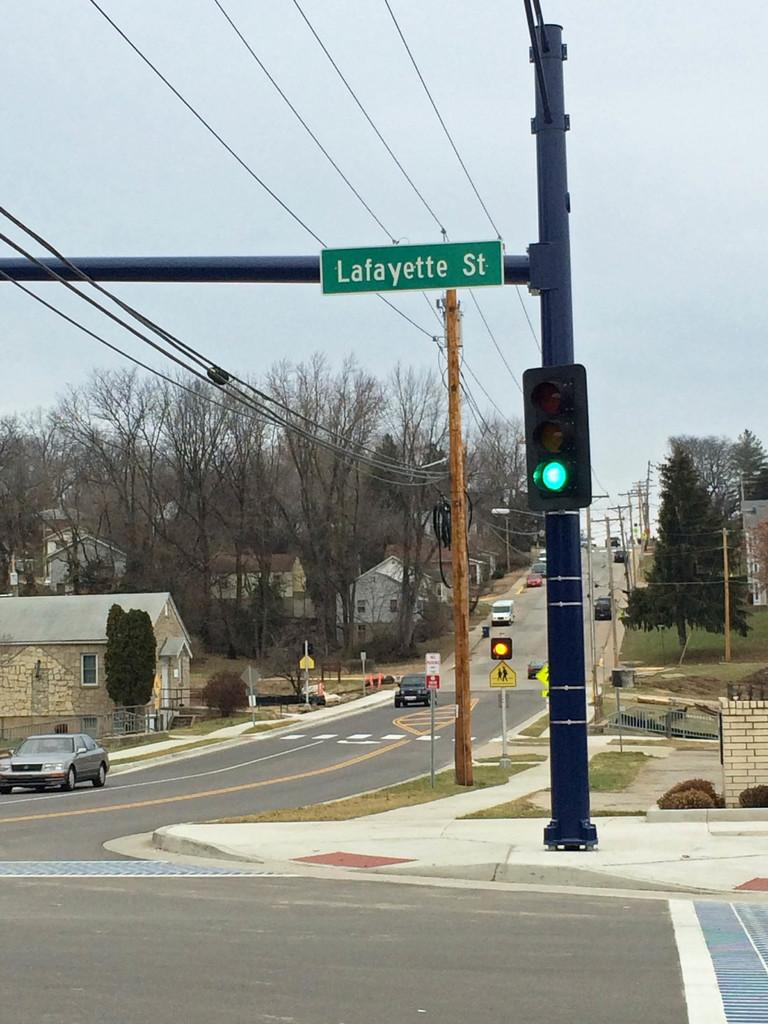<image>
Render a clear and concise summary of the photo. A green light at the Lafayette Street intersection. 